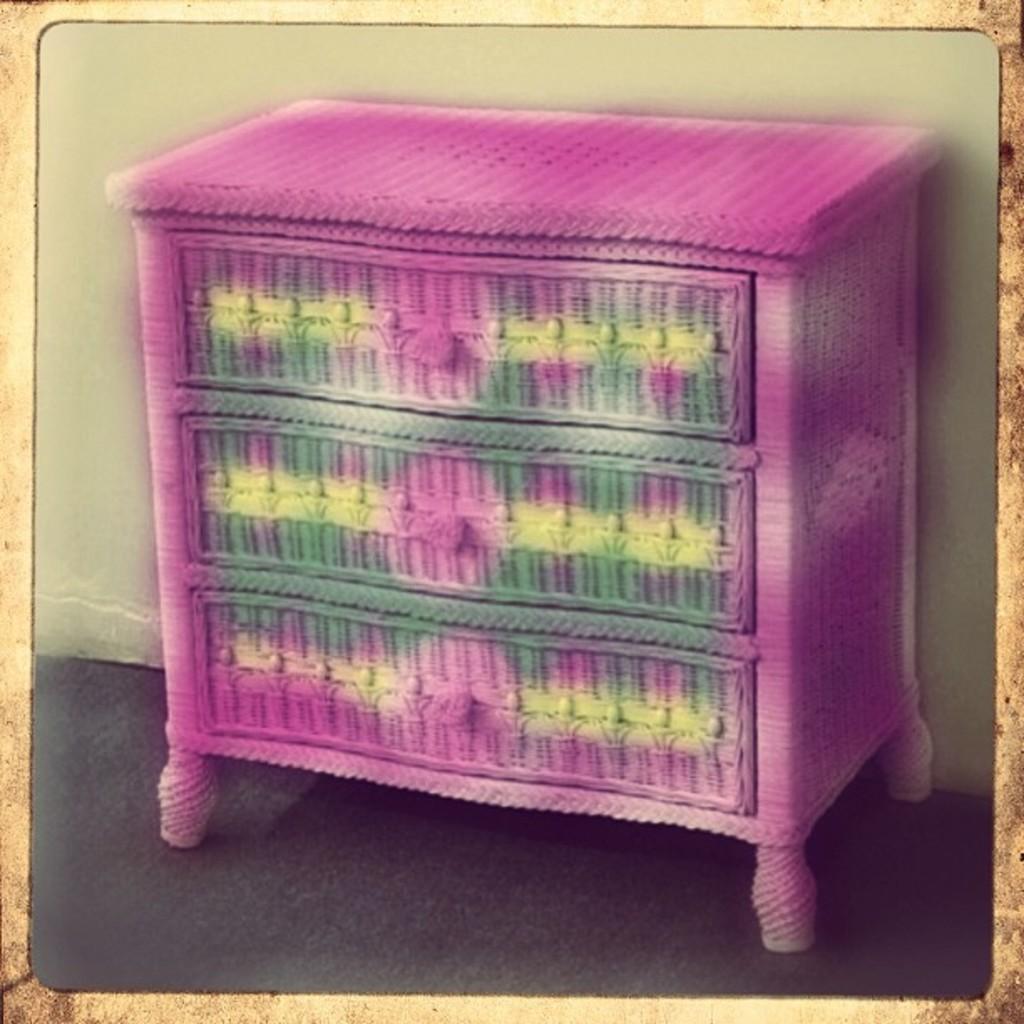Describe this image in one or two sentences. In this image I can see there is a table with different colors and there are few drawers. And at the back there is a wall. 